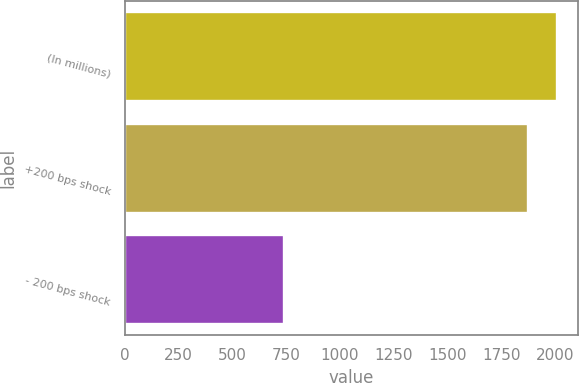<chart> <loc_0><loc_0><loc_500><loc_500><bar_chart><fcel>(In millions)<fcel>+200 bps shock<fcel>- 200 bps shock<nl><fcel>2008<fcel>1873<fcel>740<nl></chart> 